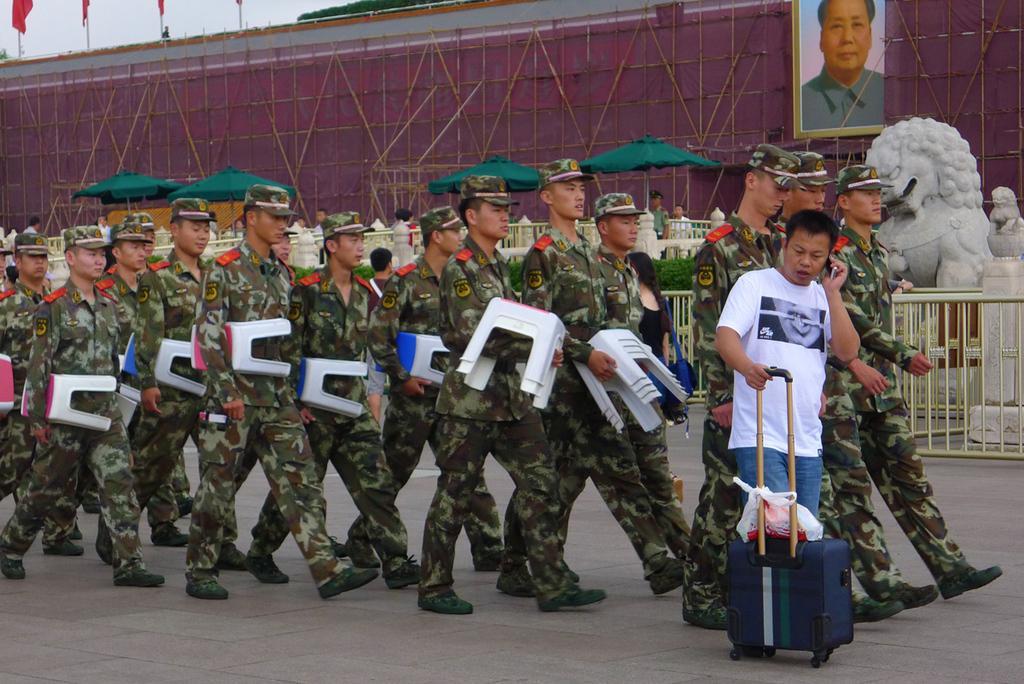How would you summarize this image in a sentence or two? In the middle of the picture, we see many people in the uniform are holding stools in their hands and they are walking on the road. Beside them, the man in white T-shirt and blue jeans is holding a suitcase in his hand and he is talking on the mobile phone. Beside them, we see a railing and a statue of the lion. Behind that, we see people are standing under the green tents. Behind them, we see a wall on which photo frame of the man is placed. In the left top of the picture, we see flags which are in red color. 